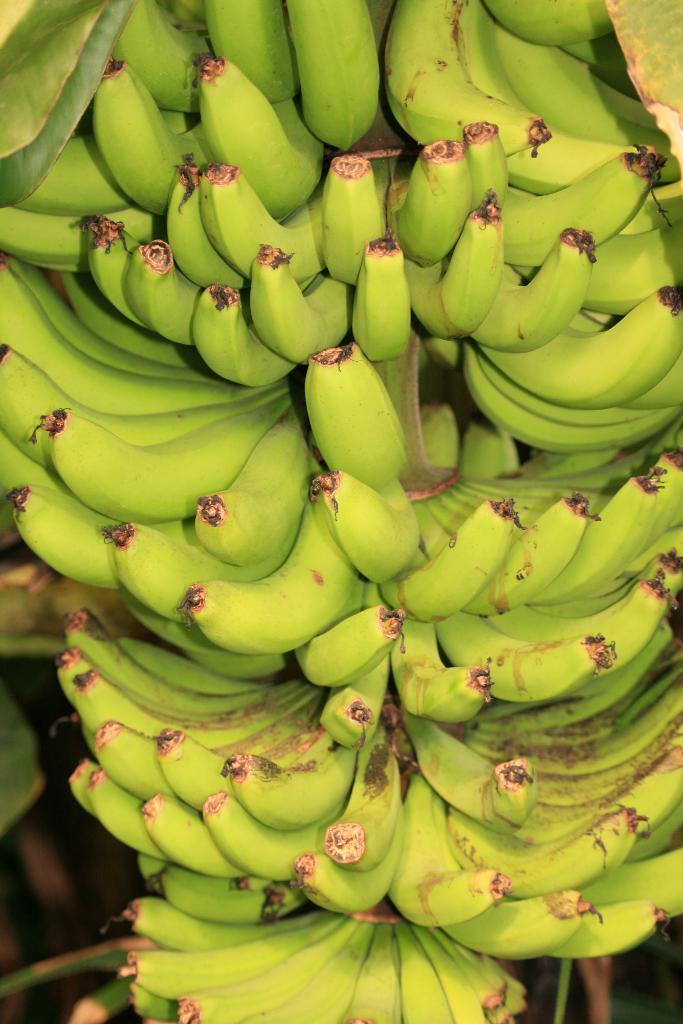Can you describe this image briefly? In this picture I can see bananas. 